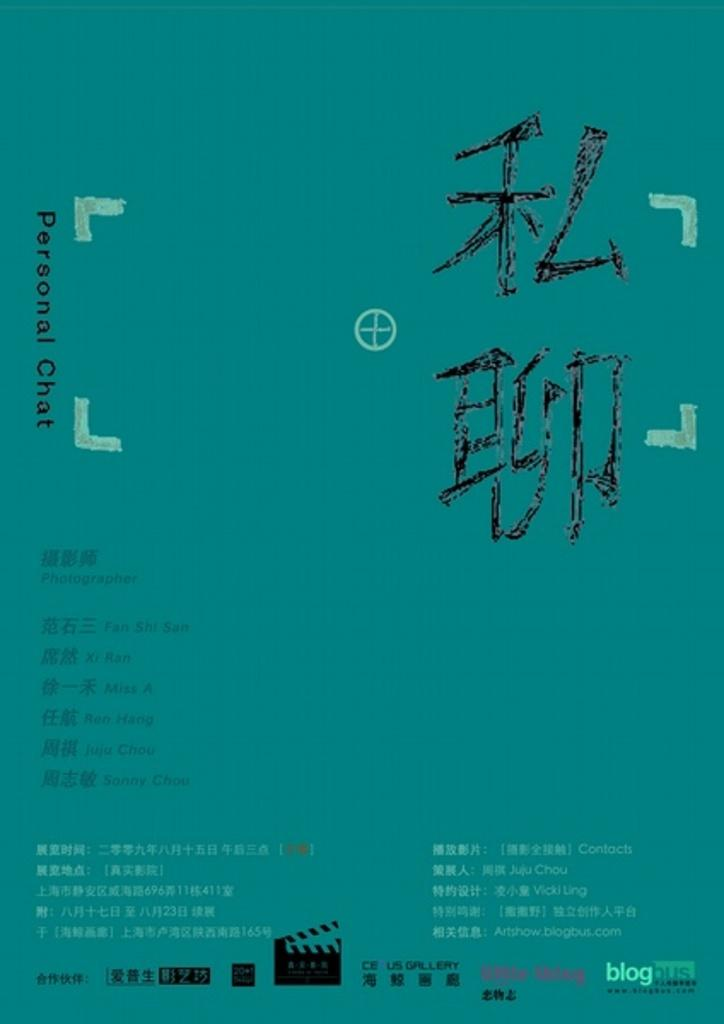<image>
Describe the image concisely. An aqua colored paper with Asian text as well as the the words "personal chat" written on it. 